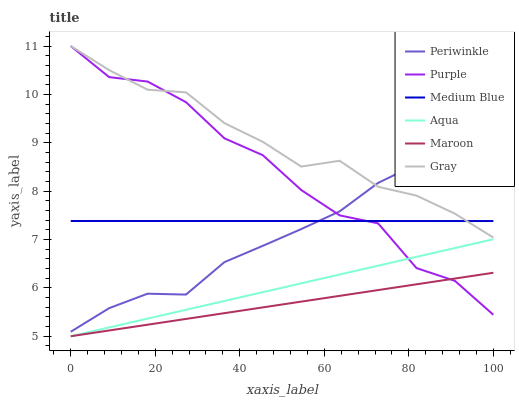Does Maroon have the minimum area under the curve?
Answer yes or no. Yes. Does Gray have the maximum area under the curve?
Answer yes or no. Yes. Does Purple have the minimum area under the curve?
Answer yes or no. No. Does Purple have the maximum area under the curve?
Answer yes or no. No. Is Aqua the smoothest?
Answer yes or no. Yes. Is Purple the roughest?
Answer yes or no. Yes. Is Purple the smoothest?
Answer yes or no. No. Is Aqua the roughest?
Answer yes or no. No. Does Aqua have the lowest value?
Answer yes or no. Yes. Does Purple have the lowest value?
Answer yes or no. No. Does Purple have the highest value?
Answer yes or no. Yes. Does Aqua have the highest value?
Answer yes or no. No. Is Maroon less than Medium Blue?
Answer yes or no. Yes. Is Gray greater than Aqua?
Answer yes or no. Yes. Does Maroon intersect Aqua?
Answer yes or no. Yes. Is Maroon less than Aqua?
Answer yes or no. No. Is Maroon greater than Aqua?
Answer yes or no. No. Does Maroon intersect Medium Blue?
Answer yes or no. No. 